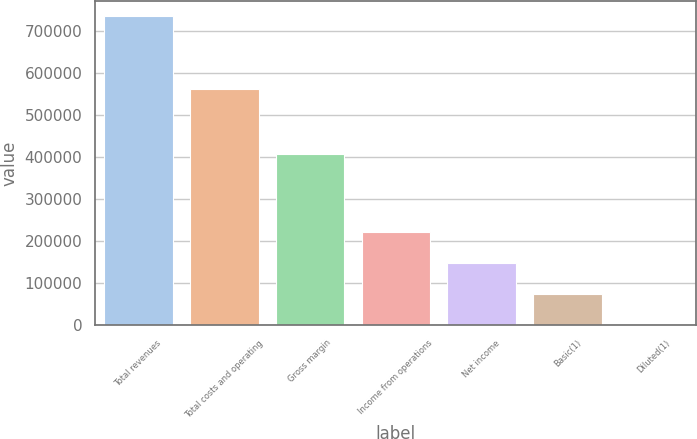Convert chart. <chart><loc_0><loc_0><loc_500><loc_500><bar_chart><fcel>Total revenues<fcel>Total costs and operating<fcel>Gross margin<fcel>Income from operations<fcel>Net income<fcel>Basic(1)<fcel>Diluted(1)<nl><fcel>734343<fcel>561329<fcel>407678<fcel>220303<fcel>146869<fcel>73435<fcel>0.77<nl></chart> 